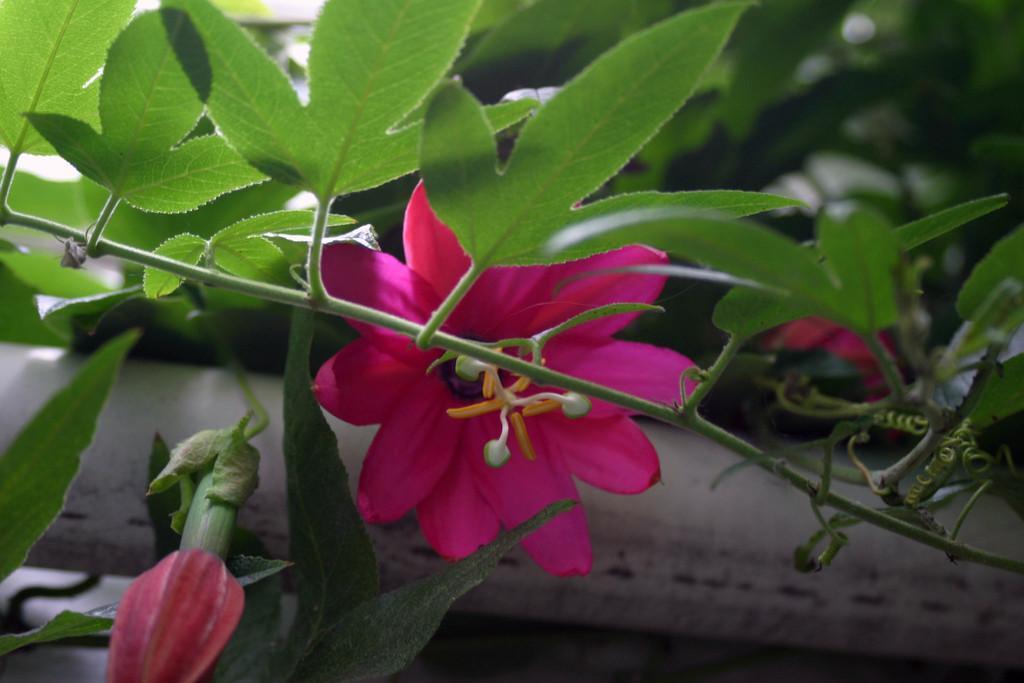Could you give a brief overview of what you see in this image? There is a plant which has flower and bud. This flower is in pink color. 